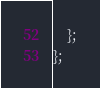Convert code to text. <code><loc_0><loc_0><loc_500><loc_500><_TypeScript_>    };
};
</code> 